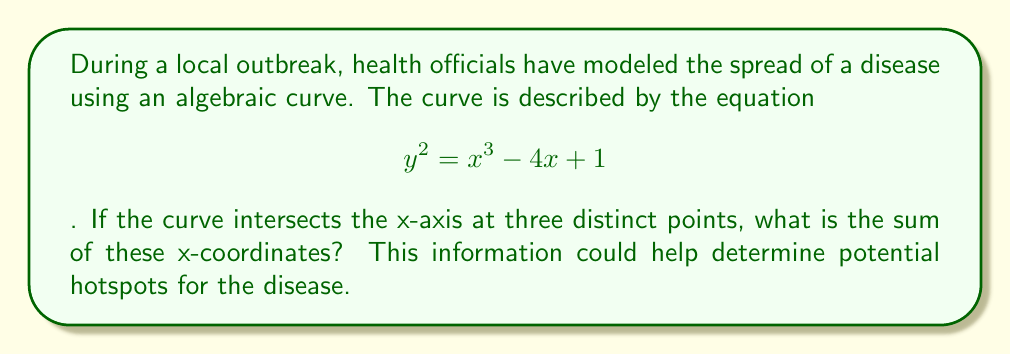Give your solution to this math problem. Let's approach this step-by-step:

1) The curve intersects the x-axis where y = 0. So, we need to solve:

   $$ 0 = x^3 - 4x + 1 $$

2) This is a cubic equation. We know it has three distinct real roots because the curve intersects the x-axis at three points.

3) Let's call these roots $r_1$, $r_2$, and $r_3$. We need to find $r_1 + r_2 + r_3$.

4) In algebra, there's a relationship between the coefficients of a polynomial and the sum of its roots. For a cubic equation $ax^3 + bx^2 + cx + d = 0$, the sum of the roots is given by $-\frac{b}{a}$.

5) In our case, $a=1$, $b=0$, $c=-4$, and $d=1$. The equation is in the form $x^3 - 4x + 1 = 0$.

6) Since $b=0$, we can conclude that:

   $$ r_1 + r_2 + r_3 = -\frac{b}{a} = -\frac{0}{1} = 0 $$

This result means that the three x-intercepts are symmetrically distributed around the y-axis, which could indicate a balanced spread pattern of the disease.
Answer: 0 